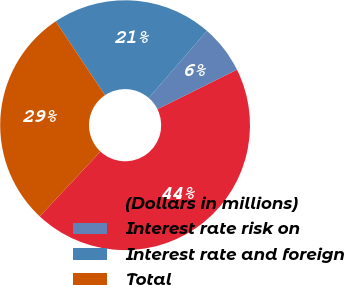Convert chart to OTSL. <chart><loc_0><loc_0><loc_500><loc_500><pie_chart><fcel>(Dollars in millions)<fcel>Interest rate risk on<fcel>Interest rate and foreign<fcel>Total<nl><fcel>44.31%<fcel>6.29%<fcel>20.75%<fcel>28.66%<nl></chart> 